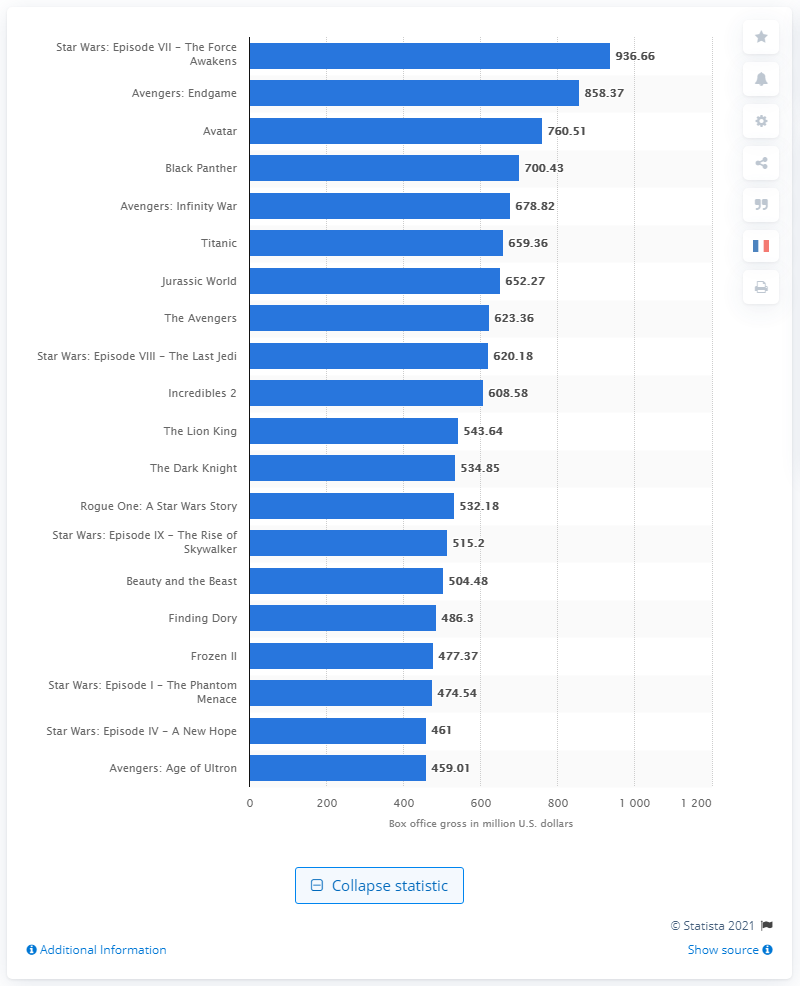List a handful of essential elements in this visual. As of January 2021, the total amount of money generated by "Star Wars: The Force Awakens" is approximately 936.66 million US dollars. As of January 2021, "Avengers: Endgame" had grossed a total of 858.37 million U.S. dollars in North American box office revenue. As of January 2021, the total box office earnings of 'Star Wars: The Rise of Skywalker' were 515.2 million dollars. 